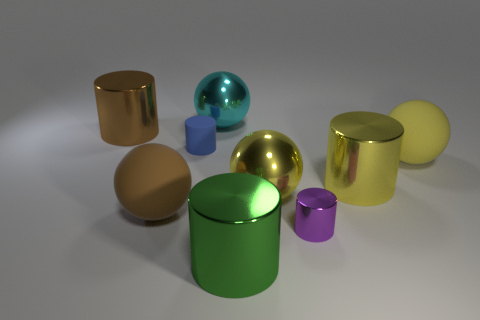How many yellow balls must be subtracted to get 1 yellow balls? 1 Subtract all yellow metal spheres. How many spheres are left? 3 Add 1 small green things. How many objects exist? 10 Subtract all balls. How many objects are left? 5 Subtract 1 cylinders. How many cylinders are left? 4 Subtract all cyan spheres. How many spheres are left? 3 Subtract 1 brown spheres. How many objects are left? 8 Subtract all red cylinders. Subtract all brown balls. How many cylinders are left? 5 Subtract all yellow spheres. How many purple cylinders are left? 1 Subtract all big yellow shiny things. Subtract all big cyan cubes. How many objects are left? 7 